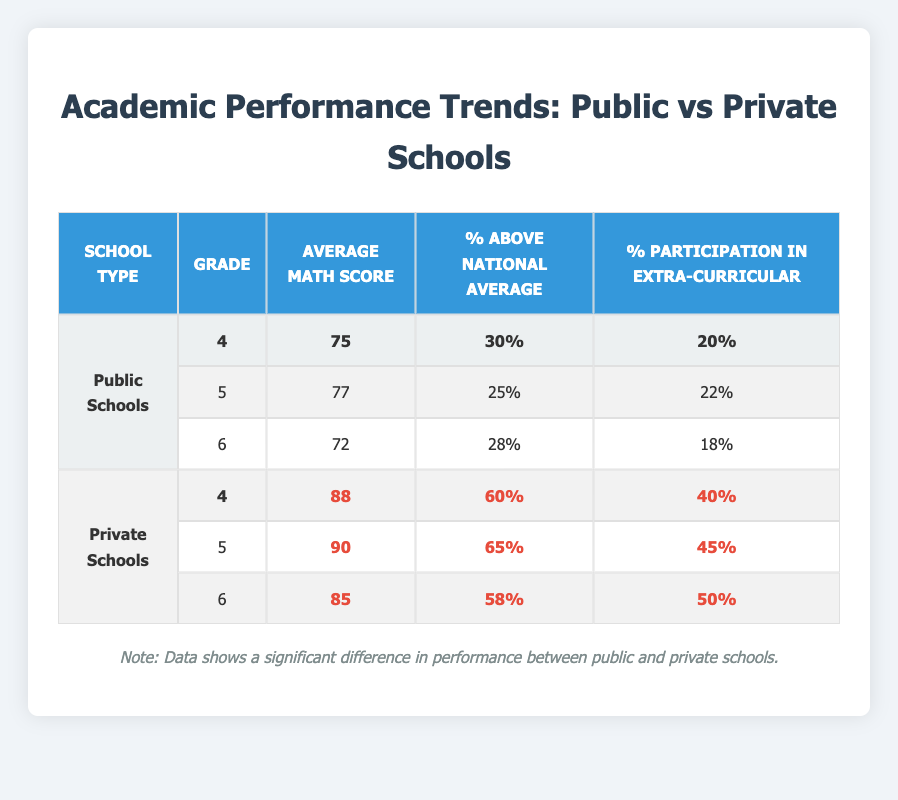What is the average math score for 6th grade public school students? The data for public school students in the 6th grade shows an average math score of 72.
Answer: 72 What percentage of 5th grade private school students scored above the national average? According to the table, 65% of 5th grade private school students scored above the national average.
Answer: 65% What is the difference in average math scores between 4th grade public and private school students? The average math score for 4th grade public school students is 75, while for private school students it is 88. The difference is 88 - 75 = 13.
Answer: 13 Did any grade level in public schools have a higher percentage of students above the national average than the 4th grade in private schools? The 4th grade private school students had 60% above the national average. The percentages for public schools are 30% (4th), 25% (5th), and 28% (6th), all of which are lower than 60%.
Answer: No What is the overall average math score for public school students across all three grades? The average math scores for public school students are 75, 77, and 72. To find the overall average: (75 + 77 + 72) / 3 = 224 / 3 = 74.67, which rounds to 75.
Answer: 75 How many percentage points higher is the participation in extra-curricular activities for 6th grade private school students compared to their public school counterparts? The percentage of 6th grade private school students participating in extra-curricular activities is 50%, while it's 18% for public school students. The difference is 50 - 18 = 32 percentage points.
Answer: 32 Which school type has a higher overall percentage of students participating in extra-curricular activities? For public schools, the participation percentages are 20%, 22%, and 18%. For private schools, they are 40%, 45%, and 50%. Averaging these: Public: (20 + 22 + 18) / 3 = 20; Private: (40 + 45 + 50) / 3 = 45. Private schools have a higher average.
Answer: Private schools What is the highest average math score among all students in the table? The highest average math score is 90, which belongs to 5th grade private school students.
Answer: 90 